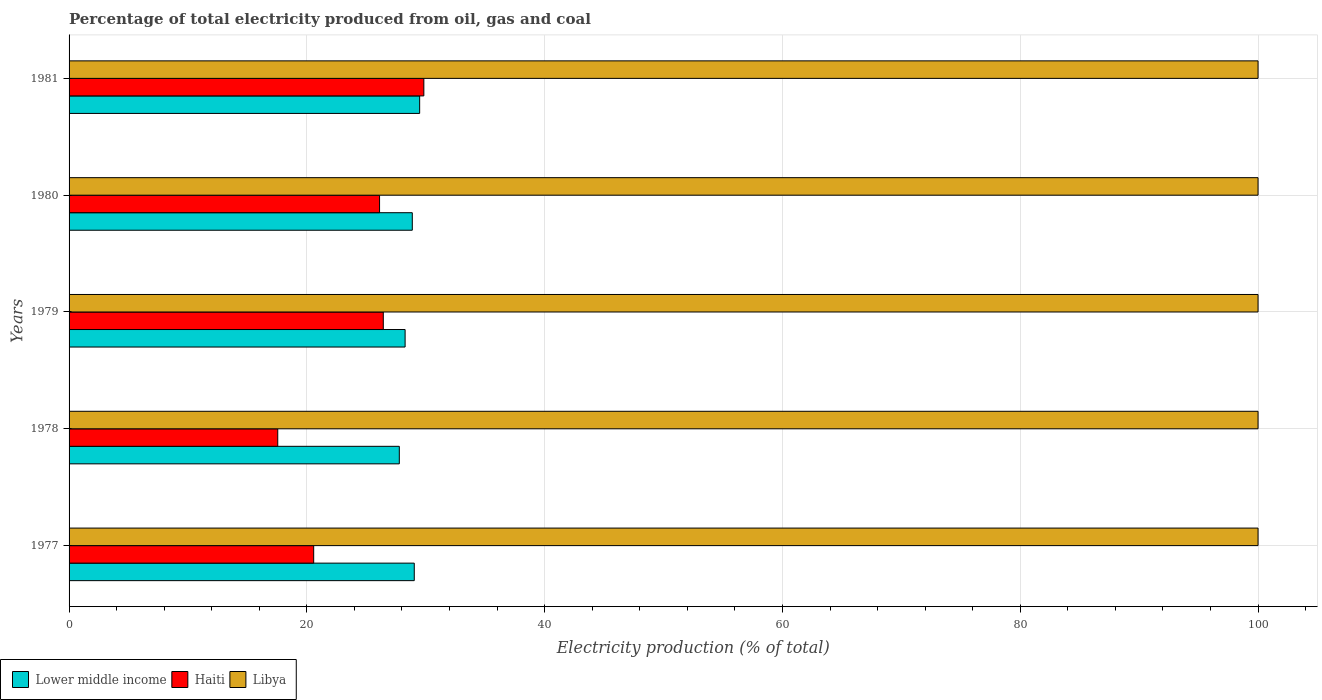How many groups of bars are there?
Provide a succinct answer. 5. Are the number of bars per tick equal to the number of legend labels?
Your answer should be compact. Yes. Are the number of bars on each tick of the Y-axis equal?
Provide a succinct answer. Yes. How many bars are there on the 1st tick from the top?
Provide a succinct answer. 3. How many bars are there on the 3rd tick from the bottom?
Your answer should be compact. 3. Across all years, what is the maximum electricity production in in Lower middle income?
Your answer should be compact. 29.49. Across all years, what is the minimum electricity production in in Lower middle income?
Provide a short and direct response. 27.78. In which year was the electricity production in in Lower middle income maximum?
Give a very brief answer. 1981. In which year was the electricity production in in Libya minimum?
Keep it short and to the point. 1977. What is the difference between the electricity production in in Lower middle income in 1980 and that in 1981?
Your answer should be compact. -0.62. What is the difference between the electricity production in in Haiti in 1980 and the electricity production in in Libya in 1978?
Provide a succinct answer. -73.89. In the year 1977, what is the difference between the electricity production in in Lower middle income and electricity production in in Haiti?
Your answer should be very brief. 8.46. What is the ratio of the electricity production in in Libya in 1977 to that in 1979?
Make the answer very short. 1. Is the electricity production in in Libya in 1977 less than that in 1981?
Offer a terse response. No. What is the difference between the highest and the second highest electricity production in in Haiti?
Offer a very short reply. 3.41. What is the difference between the highest and the lowest electricity production in in Haiti?
Keep it short and to the point. 12.29. In how many years, is the electricity production in in Lower middle income greater than the average electricity production in in Lower middle income taken over all years?
Offer a very short reply. 3. What does the 2nd bar from the top in 1977 represents?
Your answer should be compact. Haiti. What does the 2nd bar from the bottom in 1977 represents?
Your answer should be compact. Haiti. Is it the case that in every year, the sum of the electricity production in in Libya and electricity production in in Haiti is greater than the electricity production in in Lower middle income?
Offer a terse response. Yes. Does the graph contain any zero values?
Your answer should be very brief. No. Does the graph contain grids?
Provide a short and direct response. Yes. What is the title of the graph?
Keep it short and to the point. Percentage of total electricity produced from oil, gas and coal. Does "Eritrea" appear as one of the legend labels in the graph?
Your answer should be compact. No. What is the label or title of the X-axis?
Your response must be concise. Electricity production (% of total). What is the Electricity production (% of total) in Lower middle income in 1977?
Provide a succinct answer. 29.03. What is the Electricity production (% of total) in Haiti in 1977?
Provide a succinct answer. 20.57. What is the Electricity production (% of total) of Lower middle income in 1978?
Make the answer very short. 27.78. What is the Electricity production (% of total) of Haiti in 1978?
Give a very brief answer. 17.55. What is the Electricity production (% of total) of Libya in 1978?
Your answer should be very brief. 100. What is the Electricity production (% of total) of Lower middle income in 1979?
Offer a very short reply. 28.26. What is the Electricity production (% of total) of Haiti in 1979?
Give a very brief answer. 26.43. What is the Electricity production (% of total) in Libya in 1979?
Your answer should be very brief. 100. What is the Electricity production (% of total) in Lower middle income in 1980?
Give a very brief answer. 28.87. What is the Electricity production (% of total) of Haiti in 1980?
Make the answer very short. 26.11. What is the Electricity production (% of total) of Libya in 1980?
Provide a short and direct response. 100. What is the Electricity production (% of total) of Lower middle income in 1981?
Your answer should be compact. 29.49. What is the Electricity production (% of total) of Haiti in 1981?
Offer a terse response. 29.84. Across all years, what is the maximum Electricity production (% of total) in Lower middle income?
Give a very brief answer. 29.49. Across all years, what is the maximum Electricity production (% of total) of Haiti?
Your response must be concise. 29.84. Across all years, what is the minimum Electricity production (% of total) in Lower middle income?
Your answer should be very brief. 27.78. Across all years, what is the minimum Electricity production (% of total) in Haiti?
Make the answer very short. 17.55. Across all years, what is the minimum Electricity production (% of total) in Libya?
Keep it short and to the point. 100. What is the total Electricity production (% of total) in Lower middle income in the graph?
Make the answer very short. 143.43. What is the total Electricity production (% of total) in Haiti in the graph?
Your answer should be very brief. 120.51. What is the difference between the Electricity production (% of total) in Lower middle income in 1977 and that in 1978?
Give a very brief answer. 1.26. What is the difference between the Electricity production (% of total) in Haiti in 1977 and that in 1978?
Offer a very short reply. 3.02. What is the difference between the Electricity production (% of total) of Libya in 1977 and that in 1978?
Offer a very short reply. 0. What is the difference between the Electricity production (% of total) in Lower middle income in 1977 and that in 1979?
Offer a very short reply. 0.77. What is the difference between the Electricity production (% of total) in Haiti in 1977 and that in 1979?
Offer a very short reply. -5.85. What is the difference between the Electricity production (% of total) in Libya in 1977 and that in 1979?
Make the answer very short. 0. What is the difference between the Electricity production (% of total) of Lower middle income in 1977 and that in 1980?
Keep it short and to the point. 0.17. What is the difference between the Electricity production (% of total) of Haiti in 1977 and that in 1980?
Your response must be concise. -5.54. What is the difference between the Electricity production (% of total) in Lower middle income in 1977 and that in 1981?
Make the answer very short. -0.45. What is the difference between the Electricity production (% of total) in Haiti in 1977 and that in 1981?
Offer a terse response. -9.26. What is the difference between the Electricity production (% of total) of Lower middle income in 1978 and that in 1979?
Your answer should be compact. -0.49. What is the difference between the Electricity production (% of total) of Haiti in 1978 and that in 1979?
Provide a short and direct response. -8.88. What is the difference between the Electricity production (% of total) of Libya in 1978 and that in 1979?
Keep it short and to the point. 0. What is the difference between the Electricity production (% of total) of Lower middle income in 1978 and that in 1980?
Provide a short and direct response. -1.09. What is the difference between the Electricity production (% of total) in Haiti in 1978 and that in 1980?
Provide a succinct answer. -8.56. What is the difference between the Electricity production (% of total) of Lower middle income in 1978 and that in 1981?
Your response must be concise. -1.71. What is the difference between the Electricity production (% of total) of Haiti in 1978 and that in 1981?
Offer a very short reply. -12.29. What is the difference between the Electricity production (% of total) in Libya in 1978 and that in 1981?
Offer a terse response. 0. What is the difference between the Electricity production (% of total) of Lower middle income in 1979 and that in 1980?
Make the answer very short. -0.6. What is the difference between the Electricity production (% of total) in Haiti in 1979 and that in 1980?
Keep it short and to the point. 0.31. What is the difference between the Electricity production (% of total) of Lower middle income in 1979 and that in 1981?
Provide a short and direct response. -1.22. What is the difference between the Electricity production (% of total) of Haiti in 1979 and that in 1981?
Keep it short and to the point. -3.41. What is the difference between the Electricity production (% of total) in Lower middle income in 1980 and that in 1981?
Offer a very short reply. -0.62. What is the difference between the Electricity production (% of total) of Haiti in 1980 and that in 1981?
Offer a very short reply. -3.72. What is the difference between the Electricity production (% of total) in Libya in 1980 and that in 1981?
Make the answer very short. 0. What is the difference between the Electricity production (% of total) in Lower middle income in 1977 and the Electricity production (% of total) in Haiti in 1978?
Give a very brief answer. 11.48. What is the difference between the Electricity production (% of total) in Lower middle income in 1977 and the Electricity production (% of total) in Libya in 1978?
Make the answer very short. -70.97. What is the difference between the Electricity production (% of total) in Haiti in 1977 and the Electricity production (% of total) in Libya in 1978?
Provide a short and direct response. -79.43. What is the difference between the Electricity production (% of total) in Lower middle income in 1977 and the Electricity production (% of total) in Haiti in 1979?
Your answer should be compact. 2.6. What is the difference between the Electricity production (% of total) of Lower middle income in 1977 and the Electricity production (% of total) of Libya in 1979?
Give a very brief answer. -70.97. What is the difference between the Electricity production (% of total) of Haiti in 1977 and the Electricity production (% of total) of Libya in 1979?
Offer a terse response. -79.43. What is the difference between the Electricity production (% of total) of Lower middle income in 1977 and the Electricity production (% of total) of Haiti in 1980?
Your response must be concise. 2.92. What is the difference between the Electricity production (% of total) in Lower middle income in 1977 and the Electricity production (% of total) in Libya in 1980?
Keep it short and to the point. -70.97. What is the difference between the Electricity production (% of total) of Haiti in 1977 and the Electricity production (% of total) of Libya in 1980?
Give a very brief answer. -79.43. What is the difference between the Electricity production (% of total) of Lower middle income in 1977 and the Electricity production (% of total) of Haiti in 1981?
Offer a very short reply. -0.81. What is the difference between the Electricity production (% of total) in Lower middle income in 1977 and the Electricity production (% of total) in Libya in 1981?
Keep it short and to the point. -70.97. What is the difference between the Electricity production (% of total) in Haiti in 1977 and the Electricity production (% of total) in Libya in 1981?
Ensure brevity in your answer.  -79.43. What is the difference between the Electricity production (% of total) of Lower middle income in 1978 and the Electricity production (% of total) of Haiti in 1979?
Your answer should be very brief. 1.35. What is the difference between the Electricity production (% of total) in Lower middle income in 1978 and the Electricity production (% of total) in Libya in 1979?
Your answer should be very brief. -72.22. What is the difference between the Electricity production (% of total) of Haiti in 1978 and the Electricity production (% of total) of Libya in 1979?
Make the answer very short. -82.45. What is the difference between the Electricity production (% of total) of Lower middle income in 1978 and the Electricity production (% of total) of Haiti in 1980?
Give a very brief answer. 1.66. What is the difference between the Electricity production (% of total) in Lower middle income in 1978 and the Electricity production (% of total) in Libya in 1980?
Your answer should be compact. -72.22. What is the difference between the Electricity production (% of total) of Haiti in 1978 and the Electricity production (% of total) of Libya in 1980?
Offer a terse response. -82.45. What is the difference between the Electricity production (% of total) in Lower middle income in 1978 and the Electricity production (% of total) in Haiti in 1981?
Keep it short and to the point. -2.06. What is the difference between the Electricity production (% of total) of Lower middle income in 1978 and the Electricity production (% of total) of Libya in 1981?
Keep it short and to the point. -72.22. What is the difference between the Electricity production (% of total) of Haiti in 1978 and the Electricity production (% of total) of Libya in 1981?
Offer a very short reply. -82.45. What is the difference between the Electricity production (% of total) in Lower middle income in 1979 and the Electricity production (% of total) in Haiti in 1980?
Keep it short and to the point. 2.15. What is the difference between the Electricity production (% of total) in Lower middle income in 1979 and the Electricity production (% of total) in Libya in 1980?
Your response must be concise. -71.74. What is the difference between the Electricity production (% of total) of Haiti in 1979 and the Electricity production (% of total) of Libya in 1980?
Provide a short and direct response. -73.57. What is the difference between the Electricity production (% of total) of Lower middle income in 1979 and the Electricity production (% of total) of Haiti in 1981?
Ensure brevity in your answer.  -1.58. What is the difference between the Electricity production (% of total) of Lower middle income in 1979 and the Electricity production (% of total) of Libya in 1981?
Your answer should be very brief. -71.74. What is the difference between the Electricity production (% of total) in Haiti in 1979 and the Electricity production (% of total) in Libya in 1981?
Keep it short and to the point. -73.57. What is the difference between the Electricity production (% of total) of Lower middle income in 1980 and the Electricity production (% of total) of Haiti in 1981?
Ensure brevity in your answer.  -0.97. What is the difference between the Electricity production (% of total) of Lower middle income in 1980 and the Electricity production (% of total) of Libya in 1981?
Offer a terse response. -71.13. What is the difference between the Electricity production (% of total) of Haiti in 1980 and the Electricity production (% of total) of Libya in 1981?
Offer a terse response. -73.89. What is the average Electricity production (% of total) of Lower middle income per year?
Offer a very short reply. 28.69. What is the average Electricity production (% of total) of Haiti per year?
Your answer should be compact. 24.1. In the year 1977, what is the difference between the Electricity production (% of total) in Lower middle income and Electricity production (% of total) in Haiti?
Offer a very short reply. 8.46. In the year 1977, what is the difference between the Electricity production (% of total) of Lower middle income and Electricity production (% of total) of Libya?
Offer a very short reply. -70.97. In the year 1977, what is the difference between the Electricity production (% of total) of Haiti and Electricity production (% of total) of Libya?
Provide a short and direct response. -79.43. In the year 1978, what is the difference between the Electricity production (% of total) of Lower middle income and Electricity production (% of total) of Haiti?
Ensure brevity in your answer.  10.22. In the year 1978, what is the difference between the Electricity production (% of total) in Lower middle income and Electricity production (% of total) in Libya?
Give a very brief answer. -72.22. In the year 1978, what is the difference between the Electricity production (% of total) of Haiti and Electricity production (% of total) of Libya?
Your answer should be very brief. -82.45. In the year 1979, what is the difference between the Electricity production (% of total) of Lower middle income and Electricity production (% of total) of Haiti?
Provide a short and direct response. 1.83. In the year 1979, what is the difference between the Electricity production (% of total) of Lower middle income and Electricity production (% of total) of Libya?
Your answer should be very brief. -71.74. In the year 1979, what is the difference between the Electricity production (% of total) of Haiti and Electricity production (% of total) of Libya?
Keep it short and to the point. -73.57. In the year 1980, what is the difference between the Electricity production (% of total) of Lower middle income and Electricity production (% of total) of Haiti?
Offer a terse response. 2.75. In the year 1980, what is the difference between the Electricity production (% of total) in Lower middle income and Electricity production (% of total) in Libya?
Offer a terse response. -71.13. In the year 1980, what is the difference between the Electricity production (% of total) in Haiti and Electricity production (% of total) in Libya?
Provide a short and direct response. -73.89. In the year 1981, what is the difference between the Electricity production (% of total) of Lower middle income and Electricity production (% of total) of Haiti?
Provide a short and direct response. -0.35. In the year 1981, what is the difference between the Electricity production (% of total) of Lower middle income and Electricity production (% of total) of Libya?
Provide a short and direct response. -70.51. In the year 1981, what is the difference between the Electricity production (% of total) of Haiti and Electricity production (% of total) of Libya?
Make the answer very short. -70.16. What is the ratio of the Electricity production (% of total) in Lower middle income in 1977 to that in 1978?
Offer a terse response. 1.05. What is the ratio of the Electricity production (% of total) of Haiti in 1977 to that in 1978?
Provide a short and direct response. 1.17. What is the ratio of the Electricity production (% of total) of Lower middle income in 1977 to that in 1979?
Ensure brevity in your answer.  1.03. What is the ratio of the Electricity production (% of total) in Haiti in 1977 to that in 1979?
Provide a succinct answer. 0.78. What is the ratio of the Electricity production (% of total) in Libya in 1977 to that in 1979?
Provide a succinct answer. 1. What is the ratio of the Electricity production (% of total) in Haiti in 1977 to that in 1980?
Offer a very short reply. 0.79. What is the ratio of the Electricity production (% of total) of Libya in 1977 to that in 1980?
Keep it short and to the point. 1. What is the ratio of the Electricity production (% of total) in Lower middle income in 1977 to that in 1981?
Your response must be concise. 0.98. What is the ratio of the Electricity production (% of total) of Haiti in 1977 to that in 1981?
Provide a succinct answer. 0.69. What is the ratio of the Electricity production (% of total) in Lower middle income in 1978 to that in 1979?
Your response must be concise. 0.98. What is the ratio of the Electricity production (% of total) of Haiti in 1978 to that in 1979?
Your answer should be very brief. 0.66. What is the ratio of the Electricity production (% of total) in Libya in 1978 to that in 1979?
Keep it short and to the point. 1. What is the ratio of the Electricity production (% of total) in Lower middle income in 1978 to that in 1980?
Ensure brevity in your answer.  0.96. What is the ratio of the Electricity production (% of total) in Haiti in 1978 to that in 1980?
Give a very brief answer. 0.67. What is the ratio of the Electricity production (% of total) of Lower middle income in 1978 to that in 1981?
Your answer should be very brief. 0.94. What is the ratio of the Electricity production (% of total) in Haiti in 1978 to that in 1981?
Offer a very short reply. 0.59. What is the ratio of the Electricity production (% of total) in Libya in 1978 to that in 1981?
Offer a terse response. 1. What is the ratio of the Electricity production (% of total) of Lower middle income in 1979 to that in 1980?
Give a very brief answer. 0.98. What is the ratio of the Electricity production (% of total) of Lower middle income in 1979 to that in 1981?
Make the answer very short. 0.96. What is the ratio of the Electricity production (% of total) in Haiti in 1979 to that in 1981?
Provide a succinct answer. 0.89. What is the ratio of the Electricity production (% of total) in Libya in 1979 to that in 1981?
Provide a succinct answer. 1. What is the ratio of the Electricity production (% of total) of Haiti in 1980 to that in 1981?
Your response must be concise. 0.88. What is the ratio of the Electricity production (% of total) of Libya in 1980 to that in 1981?
Offer a terse response. 1. What is the difference between the highest and the second highest Electricity production (% of total) of Lower middle income?
Make the answer very short. 0.45. What is the difference between the highest and the second highest Electricity production (% of total) of Haiti?
Offer a very short reply. 3.41. What is the difference between the highest and the second highest Electricity production (% of total) of Libya?
Your answer should be very brief. 0. What is the difference between the highest and the lowest Electricity production (% of total) of Lower middle income?
Offer a terse response. 1.71. What is the difference between the highest and the lowest Electricity production (% of total) in Haiti?
Offer a very short reply. 12.29. 